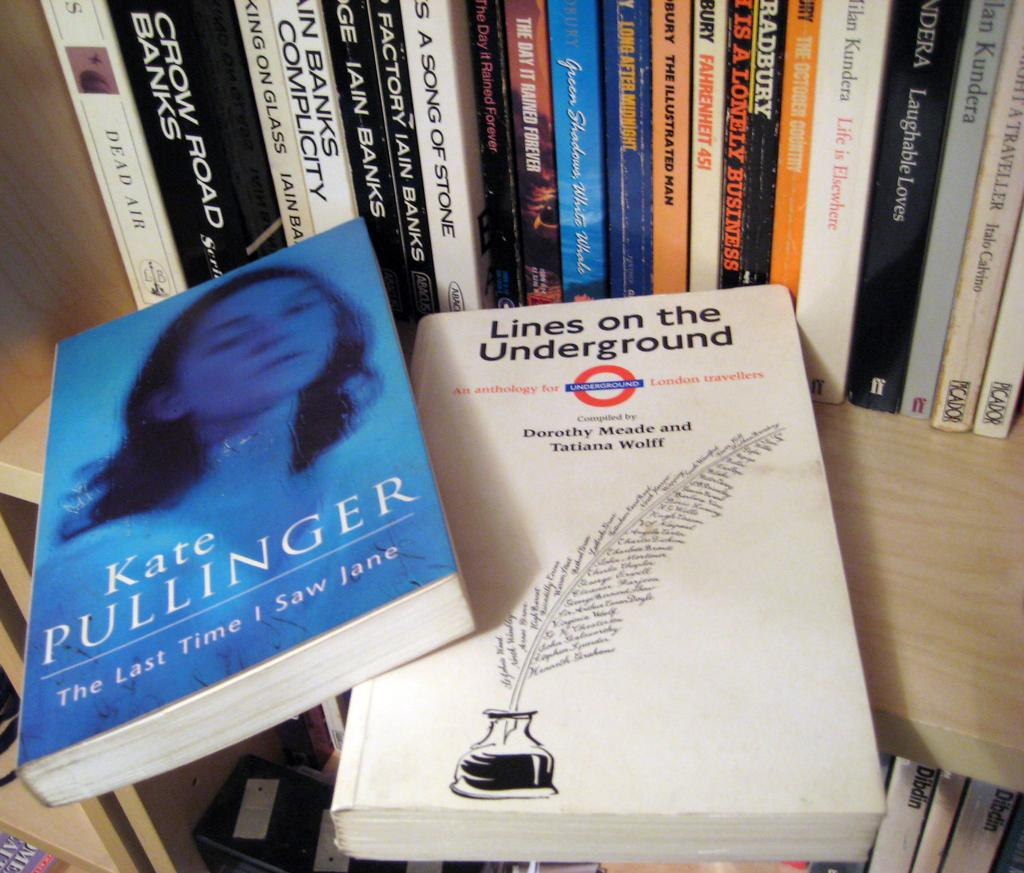<image>
Write a terse but informative summary of the picture. A book by Kate Pullinger is on top of another book. 